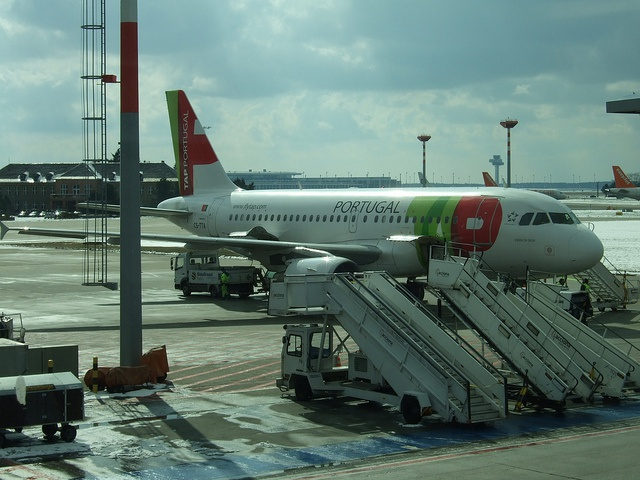Describe the objects in this image and their specific colors. I can see airplane in lightblue, teal, black, and darkgreen tones, truck in lightblue, black, and teal tones, truck in lightblue, black, teal, and darkgreen tones, airplane in lightblue, maroon, gray, and black tones, and airplane in lightblue, teal, maroon, and darkgray tones in this image. 